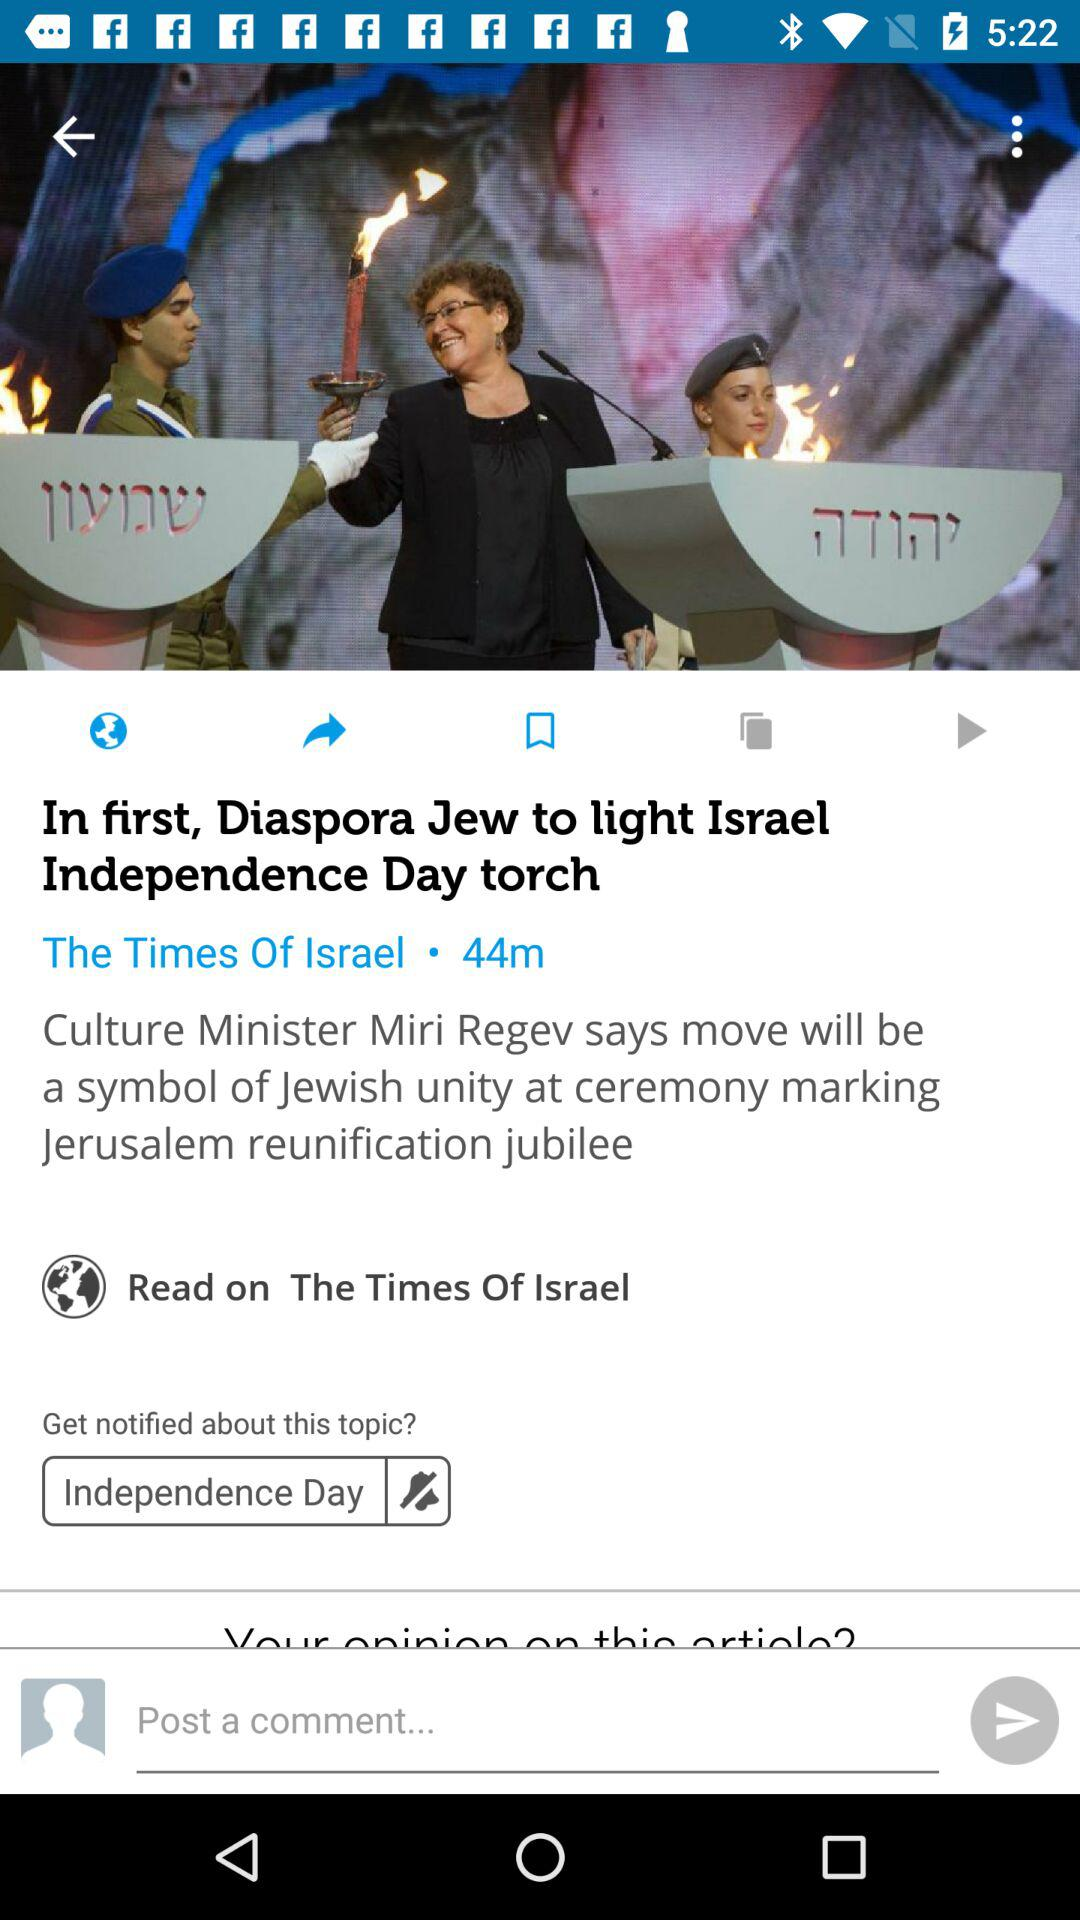When was the news posted? The news was posted 44 minutes ago. 